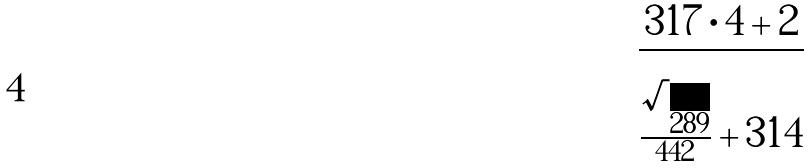<formula> <loc_0><loc_0><loc_500><loc_500>\frac { 3 1 7 \cdot 4 + 2 } { \frac { \sqrt { 2 8 9 } } { 4 4 2 } + 3 1 4 }</formula> 